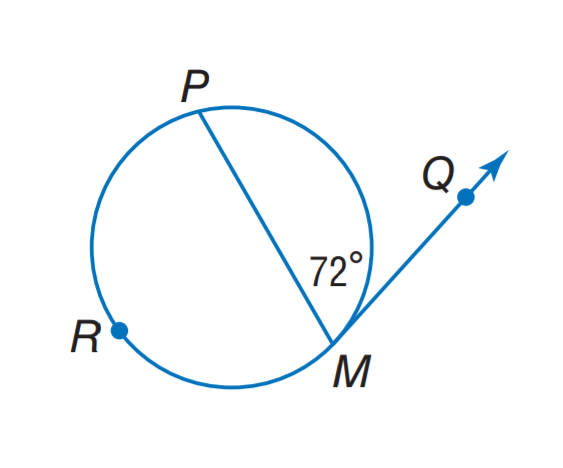Answer the mathemtical geometry problem and directly provide the correct option letter.
Question: Find m \widehat P M.
Choices: A: 36 B: 72 C: 136 D: 144 D 